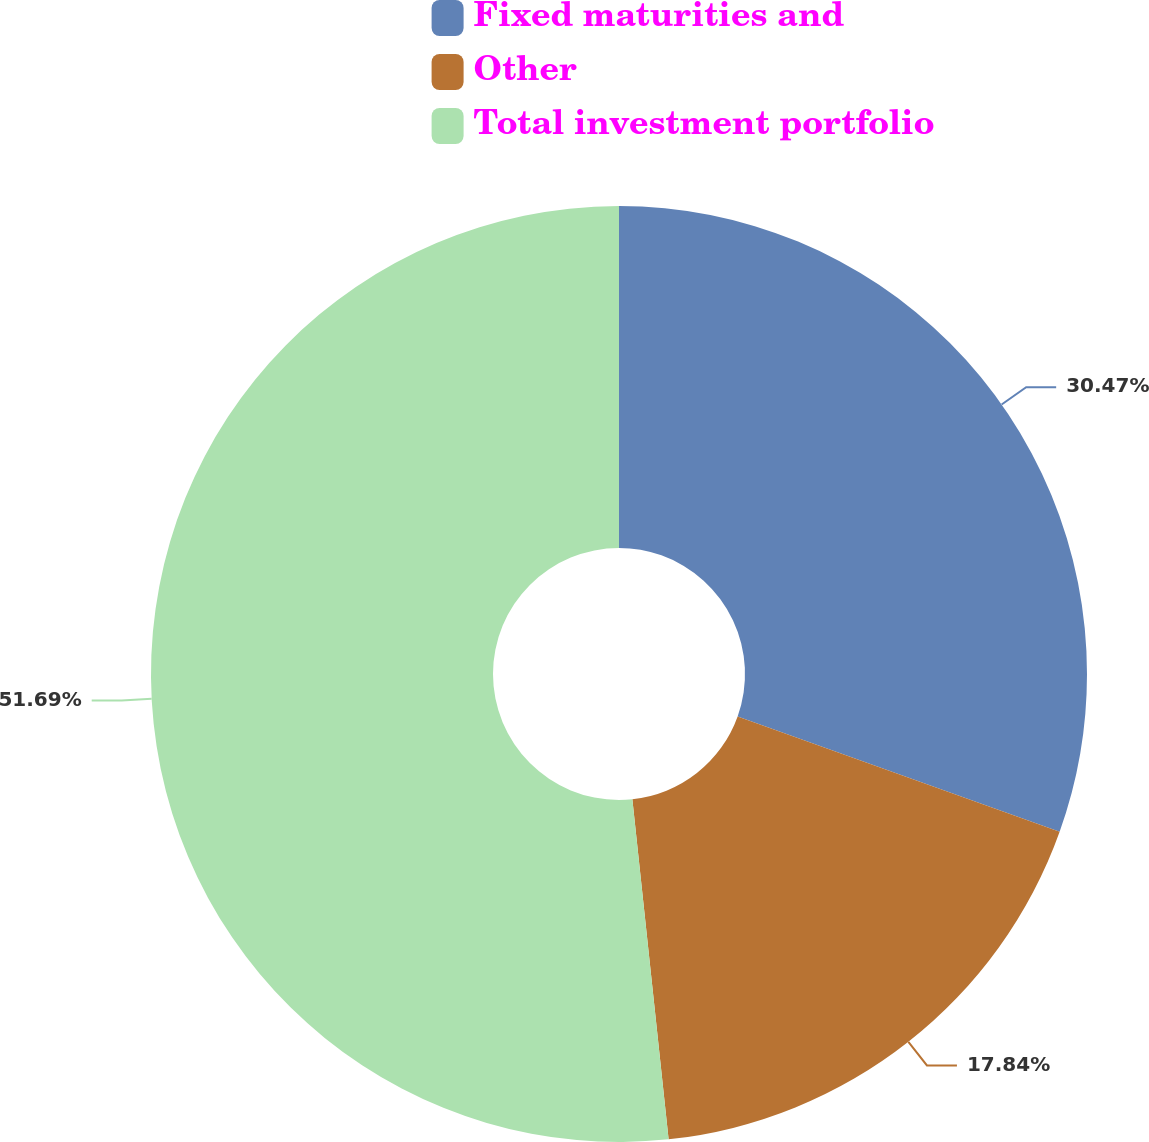<chart> <loc_0><loc_0><loc_500><loc_500><pie_chart><fcel>Fixed maturities and<fcel>Other<fcel>Total investment portfolio<nl><fcel>30.47%<fcel>17.84%<fcel>51.69%<nl></chart> 